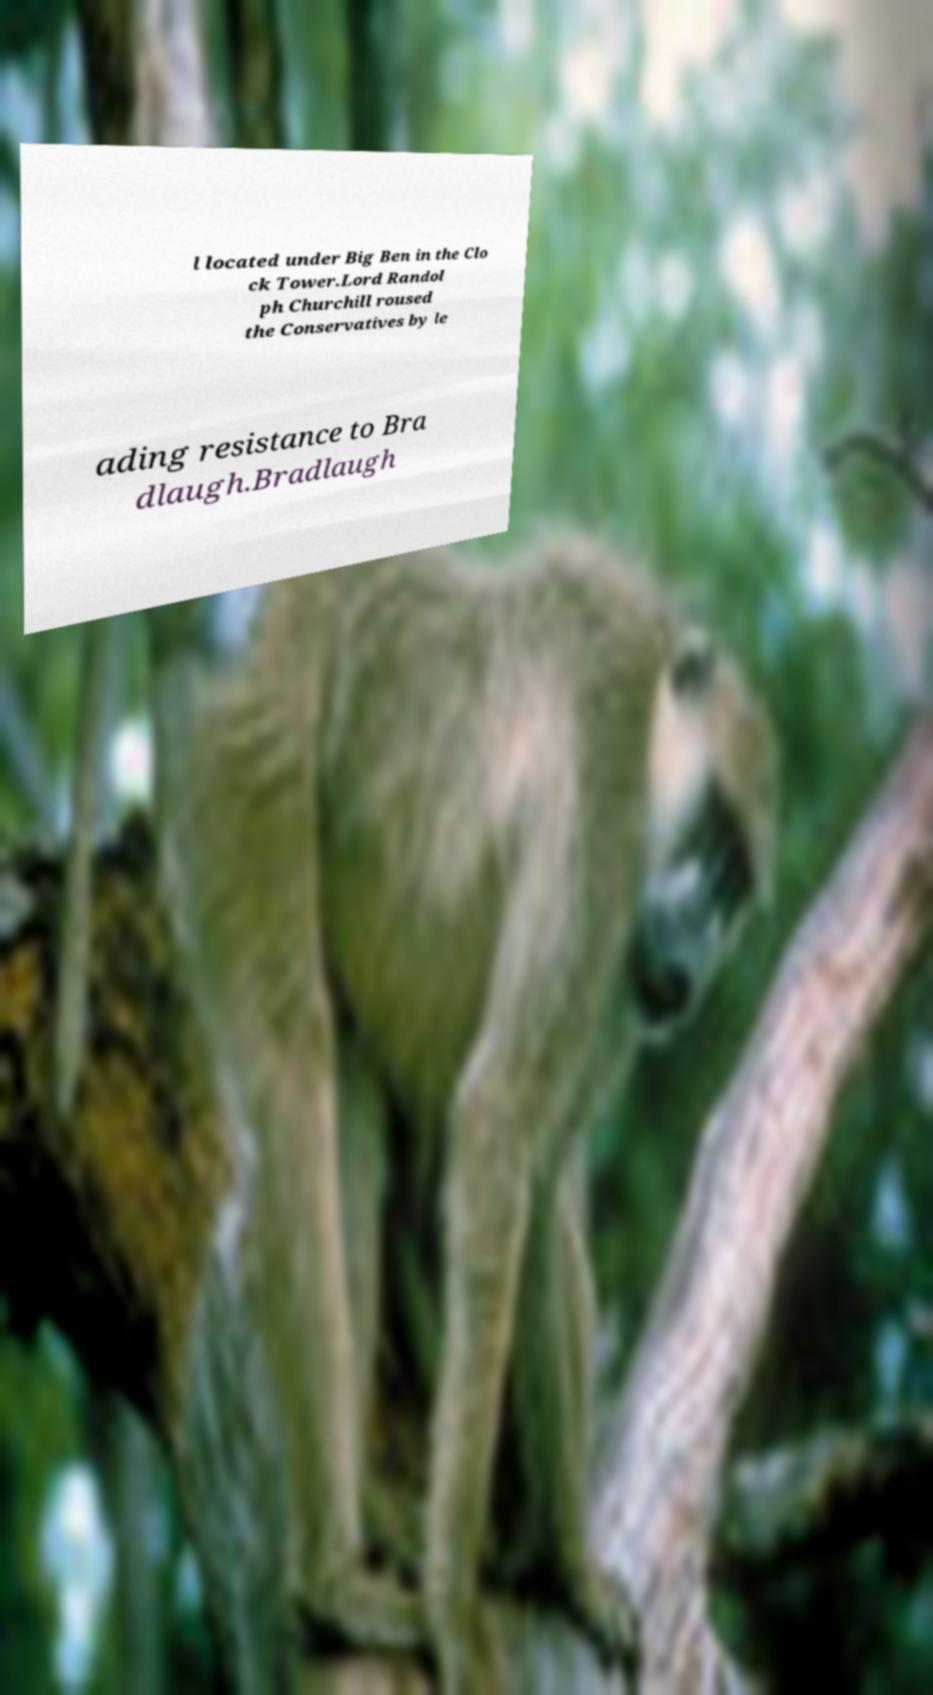Can you read and provide the text displayed in the image?This photo seems to have some interesting text. Can you extract and type it out for me? l located under Big Ben in the Clo ck Tower.Lord Randol ph Churchill roused the Conservatives by le ading resistance to Bra dlaugh.Bradlaugh 